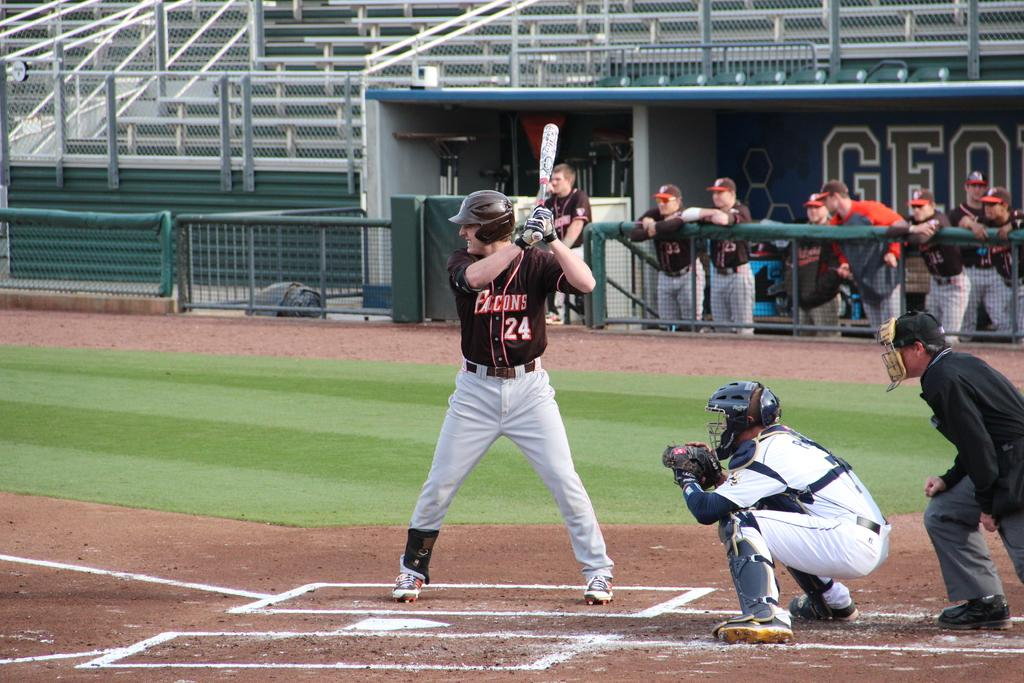<image>
Give a short and clear explanation of the subsequent image. Number 24 baseball player from the Falcons is up to bat. 